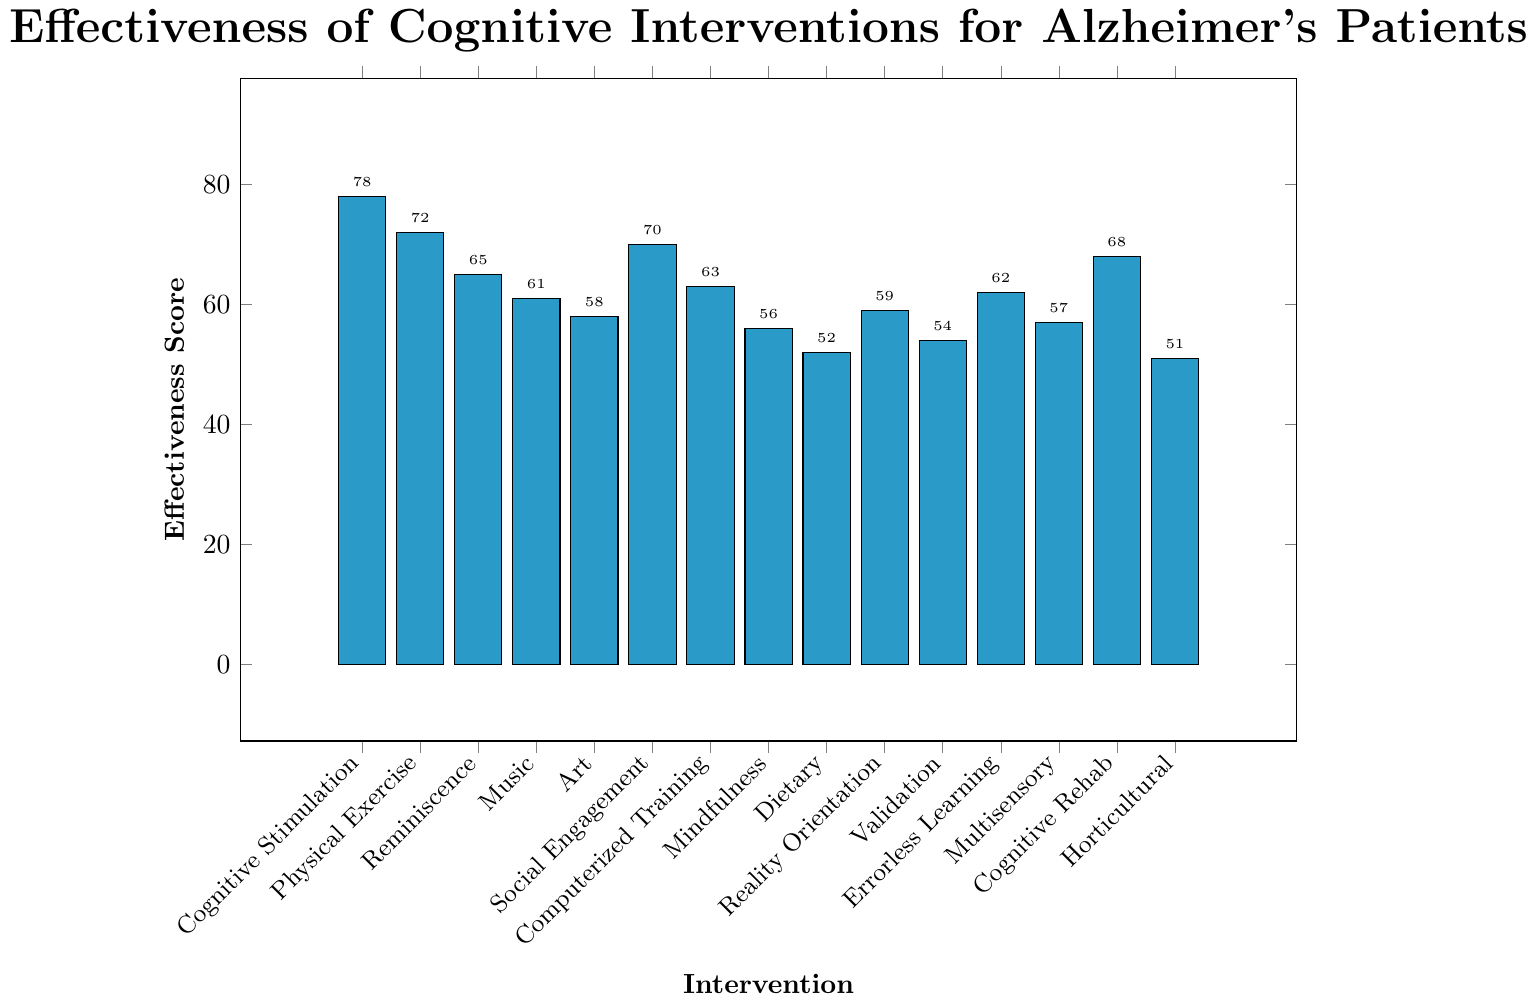Which intervention has the highest effectiveness score? The bar for "Cognitive Stimulation Therapy" is the tallest among all bars in the chart. It corresponds to the highest effectiveness score.
Answer: Cognitive Stimulation Therapy What's the difference in effectiveness score between "Cognitive Stimulation Therapy" and "Physical Exercise"? The effectiveness score for "Cognitive Stimulation Therapy" is 78, and for "Physical Exercise" it is 72. The difference is calculated as 78 - 72.
Answer: 6 What's the average effectiveness score of "Music Therapy", "Art Therapy", and "Validation Therapy"? To find the average, add the effectiveness scores of "Music Therapy" (61), "Art Therapy" (58), and "Validation Therapy" (54), then divide by 3: (61 + 58 + 54) / 3.
Answer: 57.67 Which intervention has a higher effectiveness score: "Computerized Cognitive Training" or "Reminiscence Therapy"? The effectiveness score for "Computerized Cognitive Training" is 63, and for "Reminiscence Therapy" it is 65. Since 65 is greater than 63, "Reminiscence Therapy" has a higher score.
Answer: Reminiscence Therapy How many interventions have an effectiveness score above 60? Count the bars that have an effectiveness score labeled above 60: "Cognitive Stimulation Therapy" (78), "Physical Exercise" (72), "Reminiscence Therapy" (65), "Music Therapy" (61), "Social Engagement Activities" (70), "Computerized Cognitive Training" (63), "Errorless Learning" (62), "Cognitive Rehabilitation" (68). There are 8 such interventions.
Answer: 8 What is the median effectiveness score among all interventions? List all effectiveness scores in ascending order: 51, 52, 54, 56, 57, 58, 59, 61, 62, 63, 65, 68, 70, 72, 78. The median value is the middle value of this ordered list. Since there are 15 scores, the 8th score is the median.
Answer: 61 Which intervention has the lowest effectiveness score, and what is it? The shortest bar corresponds to "Horticultural Therapy", with the lowest effectiveness score.
Answer: Horticultural Therapy, 51 